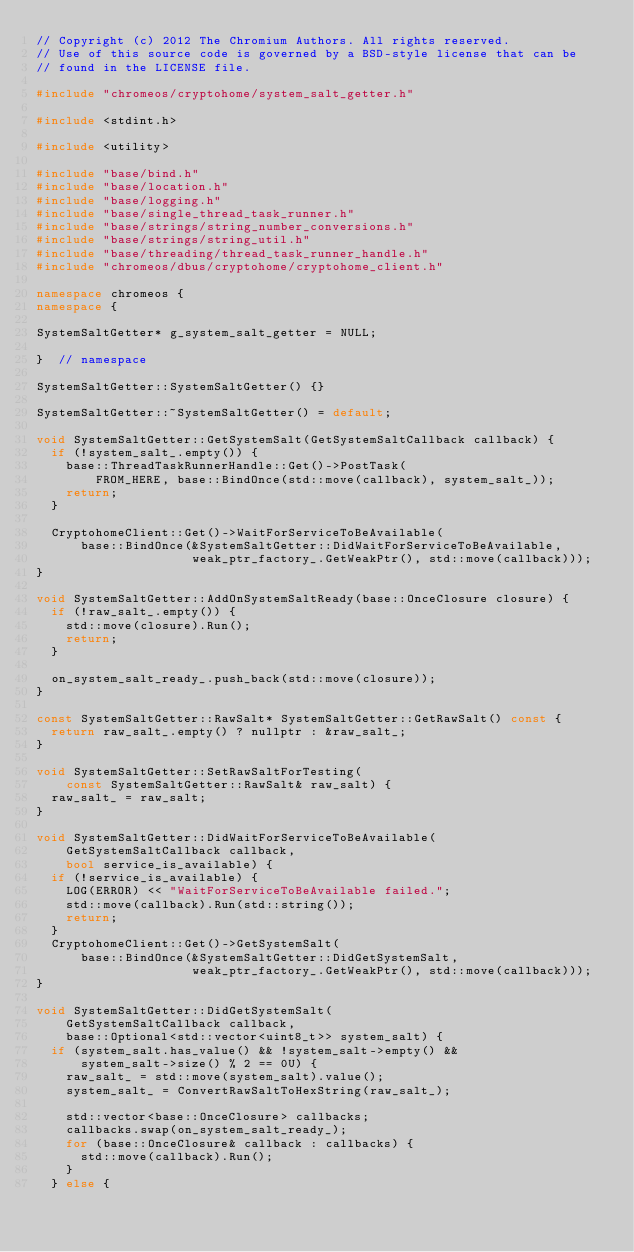<code> <loc_0><loc_0><loc_500><loc_500><_C++_>// Copyright (c) 2012 The Chromium Authors. All rights reserved.
// Use of this source code is governed by a BSD-style license that can be
// found in the LICENSE file.

#include "chromeos/cryptohome/system_salt_getter.h"

#include <stdint.h>

#include <utility>

#include "base/bind.h"
#include "base/location.h"
#include "base/logging.h"
#include "base/single_thread_task_runner.h"
#include "base/strings/string_number_conversions.h"
#include "base/strings/string_util.h"
#include "base/threading/thread_task_runner_handle.h"
#include "chromeos/dbus/cryptohome/cryptohome_client.h"

namespace chromeos {
namespace {

SystemSaltGetter* g_system_salt_getter = NULL;

}  // namespace

SystemSaltGetter::SystemSaltGetter() {}

SystemSaltGetter::~SystemSaltGetter() = default;

void SystemSaltGetter::GetSystemSalt(GetSystemSaltCallback callback) {
  if (!system_salt_.empty()) {
    base::ThreadTaskRunnerHandle::Get()->PostTask(
        FROM_HERE, base::BindOnce(std::move(callback), system_salt_));
    return;
  }

  CryptohomeClient::Get()->WaitForServiceToBeAvailable(
      base::BindOnce(&SystemSaltGetter::DidWaitForServiceToBeAvailable,
                     weak_ptr_factory_.GetWeakPtr(), std::move(callback)));
}

void SystemSaltGetter::AddOnSystemSaltReady(base::OnceClosure closure) {
  if (!raw_salt_.empty()) {
    std::move(closure).Run();
    return;
  }

  on_system_salt_ready_.push_back(std::move(closure));
}

const SystemSaltGetter::RawSalt* SystemSaltGetter::GetRawSalt() const {
  return raw_salt_.empty() ? nullptr : &raw_salt_;
}

void SystemSaltGetter::SetRawSaltForTesting(
    const SystemSaltGetter::RawSalt& raw_salt) {
  raw_salt_ = raw_salt;
}

void SystemSaltGetter::DidWaitForServiceToBeAvailable(
    GetSystemSaltCallback callback,
    bool service_is_available) {
  if (!service_is_available) {
    LOG(ERROR) << "WaitForServiceToBeAvailable failed.";
    std::move(callback).Run(std::string());
    return;
  }
  CryptohomeClient::Get()->GetSystemSalt(
      base::BindOnce(&SystemSaltGetter::DidGetSystemSalt,
                     weak_ptr_factory_.GetWeakPtr(), std::move(callback)));
}

void SystemSaltGetter::DidGetSystemSalt(
    GetSystemSaltCallback callback,
    base::Optional<std::vector<uint8_t>> system_salt) {
  if (system_salt.has_value() && !system_salt->empty() &&
      system_salt->size() % 2 == 0U) {
    raw_salt_ = std::move(system_salt).value();
    system_salt_ = ConvertRawSaltToHexString(raw_salt_);

    std::vector<base::OnceClosure> callbacks;
    callbacks.swap(on_system_salt_ready_);
    for (base::OnceClosure& callback : callbacks) {
      std::move(callback).Run();
    }
  } else {</code> 